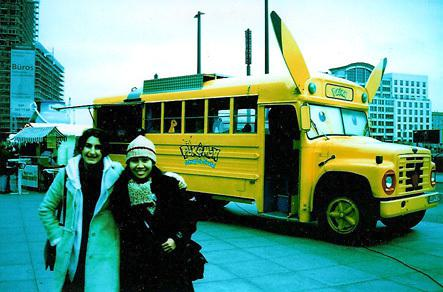How do the people in the image appear to be feeling? The two people in front of the bus are smiling and seem to be enjoying themselves. Their cheerful demeanor and relaxed posture suggest they are having a good time, perhaps participating in the event or gathering that the bus is associated with. 